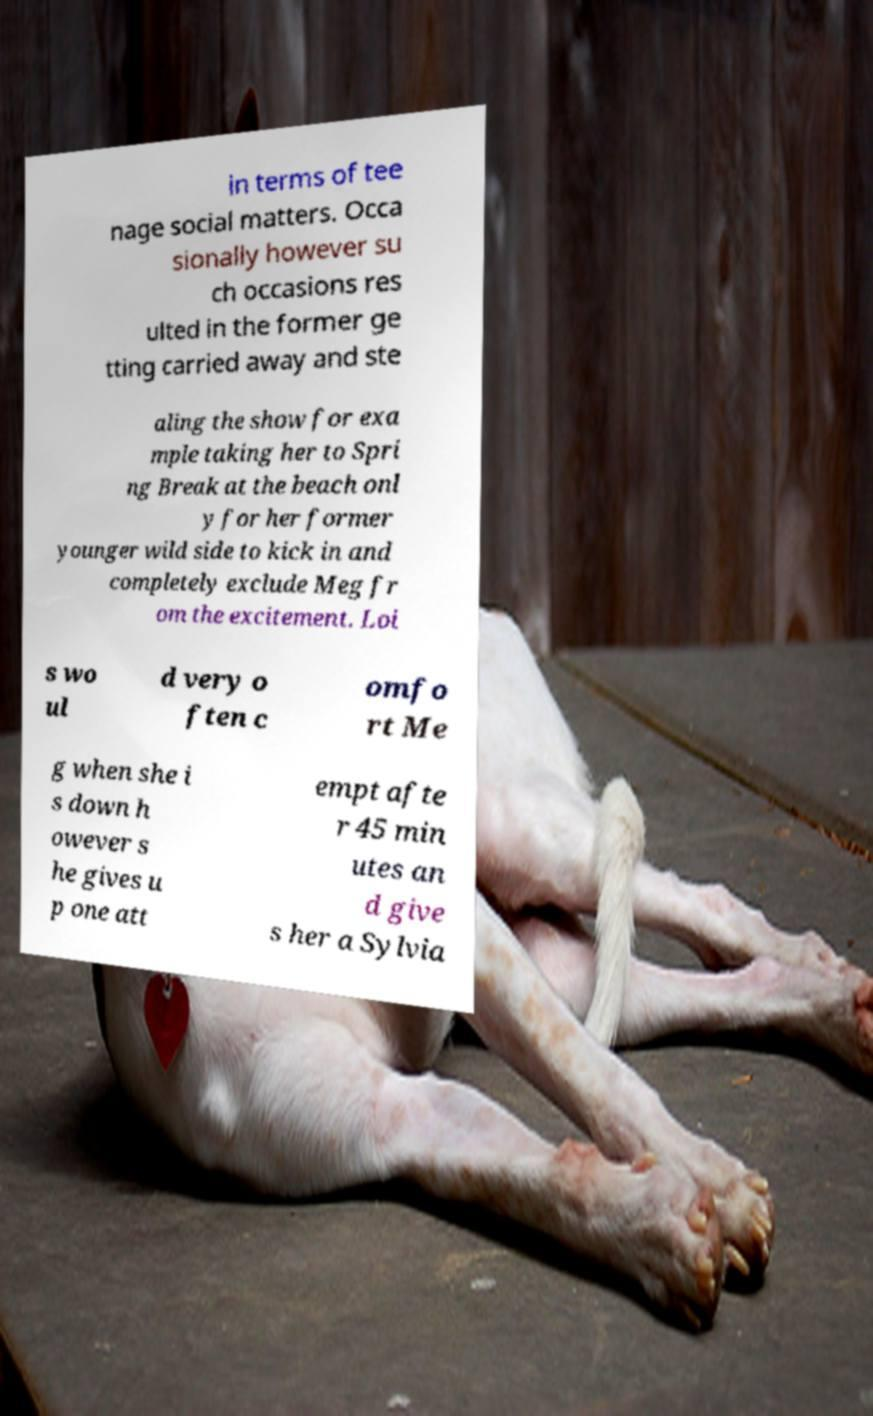What messages or text are displayed in this image? I need them in a readable, typed format. in terms of tee nage social matters. Occa sionally however su ch occasions res ulted in the former ge tting carried away and ste aling the show for exa mple taking her to Spri ng Break at the beach onl y for her former younger wild side to kick in and completely exclude Meg fr om the excitement. Loi s wo ul d very o ften c omfo rt Me g when she i s down h owever s he gives u p one att empt afte r 45 min utes an d give s her a Sylvia 